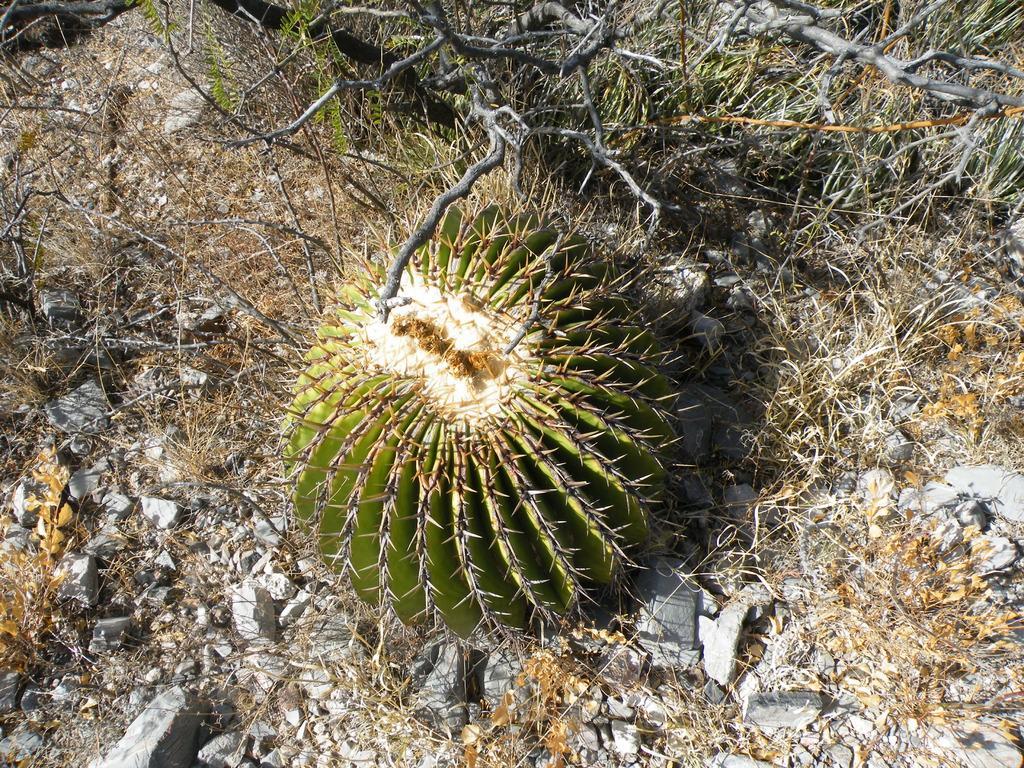In one or two sentences, can you explain what this image depicts? In this image I see the cactus, stones, grass and plants. 